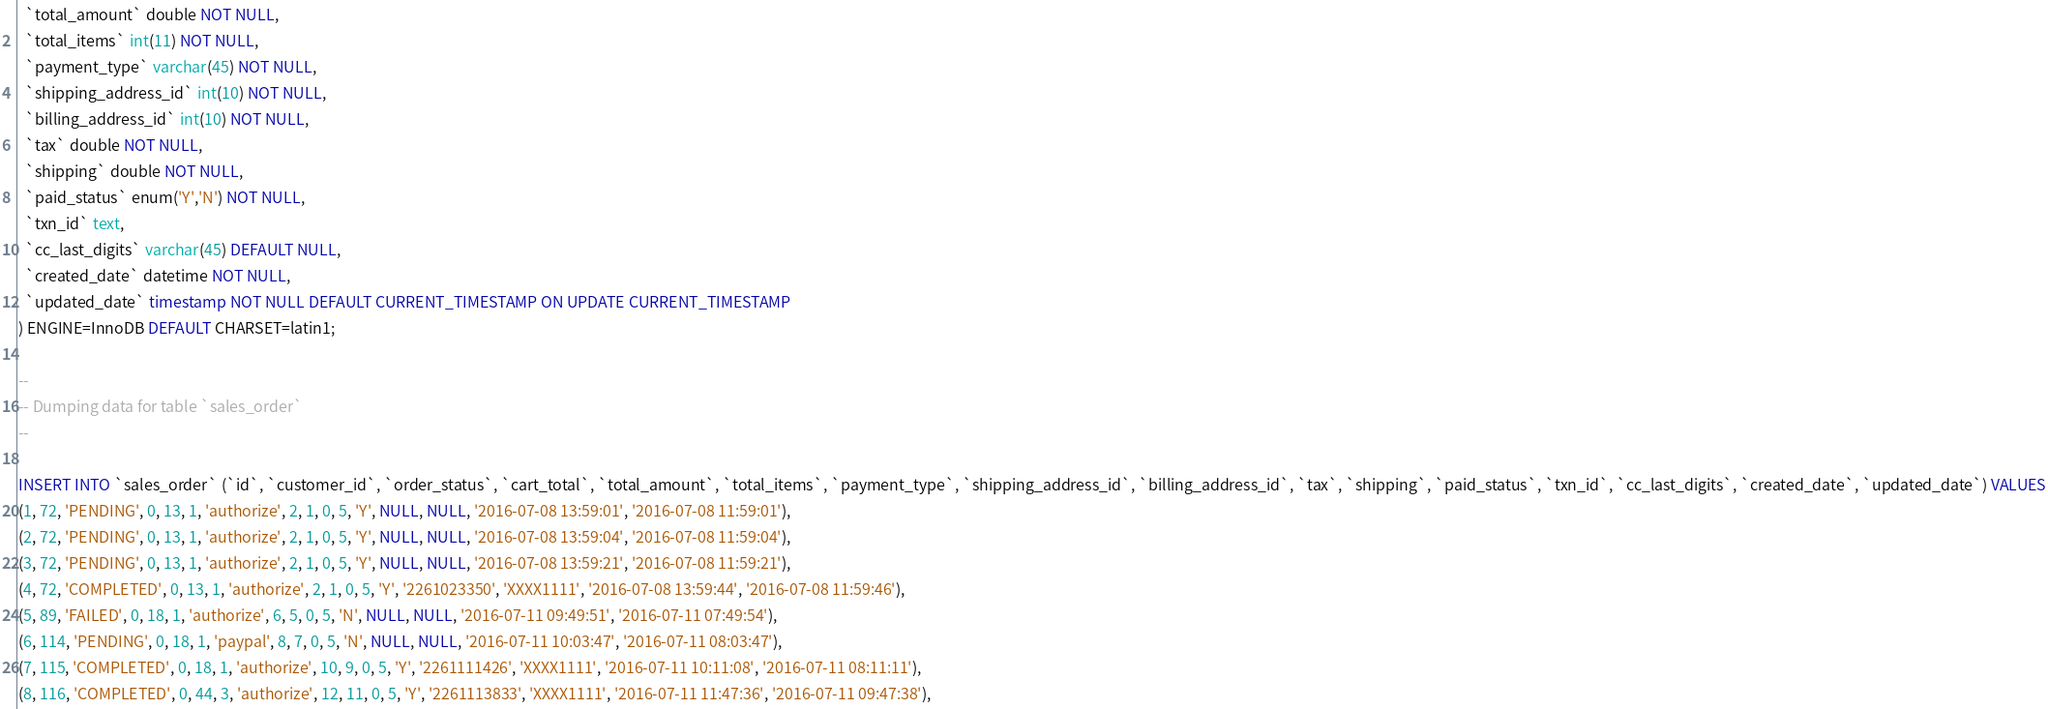Convert code to text. <code><loc_0><loc_0><loc_500><loc_500><_SQL_>  `total_amount` double NOT NULL,
  `total_items` int(11) NOT NULL,
  `payment_type` varchar(45) NOT NULL,
  `shipping_address_id` int(10) NOT NULL,
  `billing_address_id` int(10) NOT NULL,
  `tax` double NOT NULL,
  `shipping` double NOT NULL,
  `paid_status` enum('Y','N') NOT NULL,
  `txn_id` text,
  `cc_last_digits` varchar(45) DEFAULT NULL,
  `created_date` datetime NOT NULL,
  `updated_date` timestamp NOT NULL DEFAULT CURRENT_TIMESTAMP ON UPDATE CURRENT_TIMESTAMP
) ENGINE=InnoDB DEFAULT CHARSET=latin1;

--
-- Dumping data for table `sales_order`
--

INSERT INTO `sales_order` (`id`, `customer_id`, `order_status`, `cart_total`, `total_amount`, `total_items`, `payment_type`, `shipping_address_id`, `billing_address_id`, `tax`, `shipping`, `paid_status`, `txn_id`, `cc_last_digits`, `created_date`, `updated_date`) VALUES
(1, 72, 'PENDING', 0, 13, 1, 'authorize', 2, 1, 0, 5, 'Y', NULL, NULL, '2016-07-08 13:59:01', '2016-07-08 11:59:01'),
(2, 72, 'PENDING', 0, 13, 1, 'authorize', 2, 1, 0, 5, 'Y', NULL, NULL, '2016-07-08 13:59:04', '2016-07-08 11:59:04'),
(3, 72, 'PENDING', 0, 13, 1, 'authorize', 2, 1, 0, 5, 'Y', NULL, NULL, '2016-07-08 13:59:21', '2016-07-08 11:59:21'),
(4, 72, 'COMPLETED', 0, 13, 1, 'authorize', 2, 1, 0, 5, 'Y', '2261023350', 'XXXX1111', '2016-07-08 13:59:44', '2016-07-08 11:59:46'),
(5, 89, 'FAILED', 0, 18, 1, 'authorize', 6, 5, 0, 5, 'N', NULL, NULL, '2016-07-11 09:49:51', '2016-07-11 07:49:54'),
(6, 114, 'PENDING', 0, 18, 1, 'paypal', 8, 7, 0, 5, 'N', NULL, NULL, '2016-07-11 10:03:47', '2016-07-11 08:03:47'),
(7, 115, 'COMPLETED', 0, 18, 1, 'authorize', 10, 9, 0, 5, 'Y', '2261111426', 'XXXX1111', '2016-07-11 10:11:08', '2016-07-11 08:11:11'),
(8, 116, 'COMPLETED', 0, 44, 3, 'authorize', 12, 11, 0, 5, 'Y', '2261113833', 'XXXX1111', '2016-07-11 11:47:36', '2016-07-11 09:47:38'),</code> 